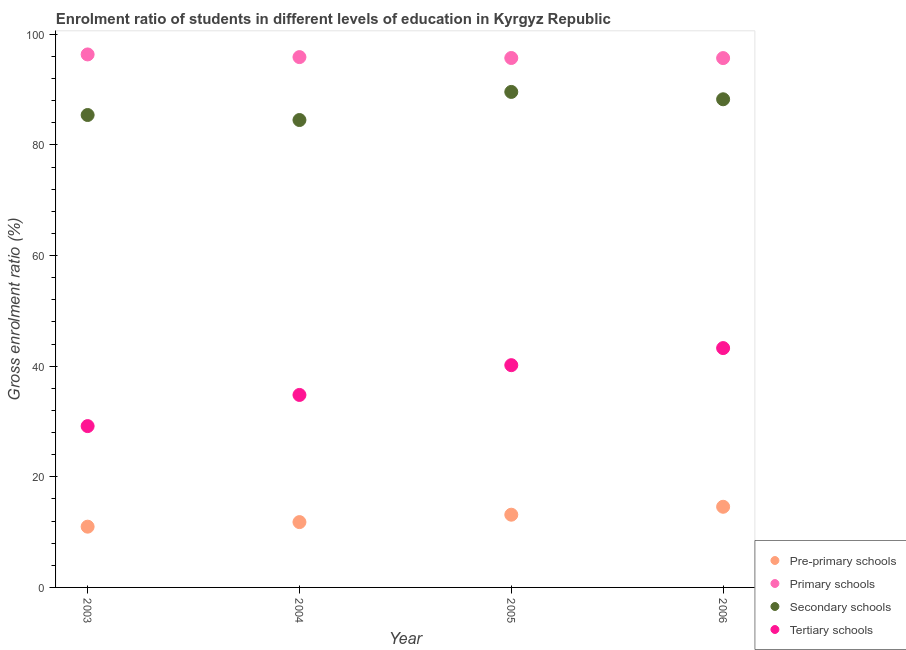How many different coloured dotlines are there?
Ensure brevity in your answer.  4. Is the number of dotlines equal to the number of legend labels?
Offer a very short reply. Yes. What is the gross enrolment ratio in pre-primary schools in 2006?
Make the answer very short. 14.58. Across all years, what is the maximum gross enrolment ratio in tertiary schools?
Offer a terse response. 43.28. Across all years, what is the minimum gross enrolment ratio in pre-primary schools?
Keep it short and to the point. 10.99. In which year was the gross enrolment ratio in pre-primary schools maximum?
Offer a terse response. 2006. What is the total gross enrolment ratio in pre-primary schools in the graph?
Offer a very short reply. 50.53. What is the difference between the gross enrolment ratio in tertiary schools in 2003 and that in 2004?
Your answer should be very brief. -5.63. What is the difference between the gross enrolment ratio in secondary schools in 2003 and the gross enrolment ratio in primary schools in 2006?
Offer a very short reply. -10.29. What is the average gross enrolment ratio in secondary schools per year?
Make the answer very short. 86.95. In the year 2005, what is the difference between the gross enrolment ratio in secondary schools and gross enrolment ratio in tertiary schools?
Give a very brief answer. 49.41. What is the ratio of the gross enrolment ratio in tertiary schools in 2005 to that in 2006?
Your answer should be compact. 0.93. Is the difference between the gross enrolment ratio in tertiary schools in 2003 and 2006 greater than the difference between the gross enrolment ratio in secondary schools in 2003 and 2006?
Provide a succinct answer. No. What is the difference between the highest and the second highest gross enrolment ratio in primary schools?
Make the answer very short. 0.48. What is the difference between the highest and the lowest gross enrolment ratio in tertiary schools?
Your answer should be very brief. 14.11. In how many years, is the gross enrolment ratio in primary schools greater than the average gross enrolment ratio in primary schools taken over all years?
Offer a terse response. 1. Is the sum of the gross enrolment ratio in primary schools in 2004 and 2005 greater than the maximum gross enrolment ratio in secondary schools across all years?
Give a very brief answer. Yes. Is it the case that in every year, the sum of the gross enrolment ratio in tertiary schools and gross enrolment ratio in pre-primary schools is greater than the sum of gross enrolment ratio in primary schools and gross enrolment ratio in secondary schools?
Keep it short and to the point. No. Is it the case that in every year, the sum of the gross enrolment ratio in pre-primary schools and gross enrolment ratio in primary schools is greater than the gross enrolment ratio in secondary schools?
Keep it short and to the point. Yes. Does the gross enrolment ratio in tertiary schools monotonically increase over the years?
Offer a terse response. Yes. Is the gross enrolment ratio in tertiary schools strictly less than the gross enrolment ratio in pre-primary schools over the years?
Provide a short and direct response. No. How many dotlines are there?
Keep it short and to the point. 4. Where does the legend appear in the graph?
Your answer should be compact. Bottom right. What is the title of the graph?
Your answer should be very brief. Enrolment ratio of students in different levels of education in Kyrgyz Republic. What is the label or title of the X-axis?
Your answer should be very brief. Year. What is the Gross enrolment ratio (%) of Pre-primary schools in 2003?
Provide a succinct answer. 10.99. What is the Gross enrolment ratio (%) of Primary schools in 2003?
Provide a succinct answer. 96.37. What is the Gross enrolment ratio (%) of Secondary schools in 2003?
Ensure brevity in your answer.  85.42. What is the Gross enrolment ratio (%) in Tertiary schools in 2003?
Your answer should be very brief. 29.17. What is the Gross enrolment ratio (%) of Pre-primary schools in 2004?
Make the answer very short. 11.81. What is the Gross enrolment ratio (%) of Primary schools in 2004?
Offer a very short reply. 95.89. What is the Gross enrolment ratio (%) of Secondary schools in 2004?
Give a very brief answer. 84.51. What is the Gross enrolment ratio (%) in Tertiary schools in 2004?
Provide a succinct answer. 34.8. What is the Gross enrolment ratio (%) in Pre-primary schools in 2005?
Your answer should be very brief. 13.15. What is the Gross enrolment ratio (%) in Primary schools in 2005?
Give a very brief answer. 95.73. What is the Gross enrolment ratio (%) in Secondary schools in 2005?
Make the answer very short. 89.59. What is the Gross enrolment ratio (%) in Tertiary schools in 2005?
Your answer should be compact. 40.19. What is the Gross enrolment ratio (%) of Pre-primary schools in 2006?
Provide a short and direct response. 14.58. What is the Gross enrolment ratio (%) in Primary schools in 2006?
Your answer should be compact. 95.71. What is the Gross enrolment ratio (%) of Secondary schools in 2006?
Your answer should be very brief. 88.26. What is the Gross enrolment ratio (%) of Tertiary schools in 2006?
Your answer should be compact. 43.28. Across all years, what is the maximum Gross enrolment ratio (%) of Pre-primary schools?
Your answer should be very brief. 14.58. Across all years, what is the maximum Gross enrolment ratio (%) in Primary schools?
Your answer should be very brief. 96.37. Across all years, what is the maximum Gross enrolment ratio (%) of Secondary schools?
Your response must be concise. 89.59. Across all years, what is the maximum Gross enrolment ratio (%) in Tertiary schools?
Keep it short and to the point. 43.28. Across all years, what is the minimum Gross enrolment ratio (%) in Pre-primary schools?
Keep it short and to the point. 10.99. Across all years, what is the minimum Gross enrolment ratio (%) of Primary schools?
Ensure brevity in your answer.  95.71. Across all years, what is the minimum Gross enrolment ratio (%) in Secondary schools?
Give a very brief answer. 84.51. Across all years, what is the minimum Gross enrolment ratio (%) of Tertiary schools?
Your response must be concise. 29.17. What is the total Gross enrolment ratio (%) in Pre-primary schools in the graph?
Ensure brevity in your answer.  50.53. What is the total Gross enrolment ratio (%) of Primary schools in the graph?
Your answer should be very brief. 383.69. What is the total Gross enrolment ratio (%) of Secondary schools in the graph?
Ensure brevity in your answer.  347.78. What is the total Gross enrolment ratio (%) of Tertiary schools in the graph?
Provide a succinct answer. 147.43. What is the difference between the Gross enrolment ratio (%) in Pre-primary schools in 2003 and that in 2004?
Your response must be concise. -0.83. What is the difference between the Gross enrolment ratio (%) of Primary schools in 2003 and that in 2004?
Keep it short and to the point. 0.48. What is the difference between the Gross enrolment ratio (%) in Secondary schools in 2003 and that in 2004?
Provide a short and direct response. 0.91. What is the difference between the Gross enrolment ratio (%) of Tertiary schools in 2003 and that in 2004?
Your answer should be compact. -5.63. What is the difference between the Gross enrolment ratio (%) in Pre-primary schools in 2003 and that in 2005?
Your answer should be compact. -2.17. What is the difference between the Gross enrolment ratio (%) of Primary schools in 2003 and that in 2005?
Your answer should be compact. 0.64. What is the difference between the Gross enrolment ratio (%) of Secondary schools in 2003 and that in 2005?
Your response must be concise. -4.17. What is the difference between the Gross enrolment ratio (%) in Tertiary schools in 2003 and that in 2005?
Offer a terse response. -11.02. What is the difference between the Gross enrolment ratio (%) in Pre-primary schools in 2003 and that in 2006?
Your answer should be very brief. -3.6. What is the difference between the Gross enrolment ratio (%) of Primary schools in 2003 and that in 2006?
Ensure brevity in your answer.  0.66. What is the difference between the Gross enrolment ratio (%) in Secondary schools in 2003 and that in 2006?
Your answer should be compact. -2.84. What is the difference between the Gross enrolment ratio (%) in Tertiary schools in 2003 and that in 2006?
Your answer should be compact. -14.11. What is the difference between the Gross enrolment ratio (%) in Pre-primary schools in 2004 and that in 2005?
Offer a terse response. -1.34. What is the difference between the Gross enrolment ratio (%) in Primary schools in 2004 and that in 2005?
Offer a very short reply. 0.16. What is the difference between the Gross enrolment ratio (%) of Secondary schools in 2004 and that in 2005?
Give a very brief answer. -5.08. What is the difference between the Gross enrolment ratio (%) in Tertiary schools in 2004 and that in 2005?
Provide a short and direct response. -5.38. What is the difference between the Gross enrolment ratio (%) in Pre-primary schools in 2004 and that in 2006?
Ensure brevity in your answer.  -2.77. What is the difference between the Gross enrolment ratio (%) of Primary schools in 2004 and that in 2006?
Give a very brief answer. 0.18. What is the difference between the Gross enrolment ratio (%) of Secondary schools in 2004 and that in 2006?
Offer a terse response. -3.75. What is the difference between the Gross enrolment ratio (%) of Tertiary schools in 2004 and that in 2006?
Keep it short and to the point. -8.47. What is the difference between the Gross enrolment ratio (%) of Pre-primary schools in 2005 and that in 2006?
Give a very brief answer. -1.43. What is the difference between the Gross enrolment ratio (%) in Primary schools in 2005 and that in 2006?
Ensure brevity in your answer.  0.02. What is the difference between the Gross enrolment ratio (%) of Secondary schools in 2005 and that in 2006?
Ensure brevity in your answer.  1.33. What is the difference between the Gross enrolment ratio (%) in Tertiary schools in 2005 and that in 2006?
Make the answer very short. -3.09. What is the difference between the Gross enrolment ratio (%) in Pre-primary schools in 2003 and the Gross enrolment ratio (%) in Primary schools in 2004?
Give a very brief answer. -84.9. What is the difference between the Gross enrolment ratio (%) of Pre-primary schools in 2003 and the Gross enrolment ratio (%) of Secondary schools in 2004?
Offer a very short reply. -73.53. What is the difference between the Gross enrolment ratio (%) in Pre-primary schools in 2003 and the Gross enrolment ratio (%) in Tertiary schools in 2004?
Your answer should be compact. -23.82. What is the difference between the Gross enrolment ratio (%) in Primary schools in 2003 and the Gross enrolment ratio (%) in Secondary schools in 2004?
Your answer should be very brief. 11.86. What is the difference between the Gross enrolment ratio (%) of Primary schools in 2003 and the Gross enrolment ratio (%) of Tertiary schools in 2004?
Offer a terse response. 61.57. What is the difference between the Gross enrolment ratio (%) in Secondary schools in 2003 and the Gross enrolment ratio (%) in Tertiary schools in 2004?
Ensure brevity in your answer.  50.61. What is the difference between the Gross enrolment ratio (%) in Pre-primary schools in 2003 and the Gross enrolment ratio (%) in Primary schools in 2005?
Keep it short and to the point. -84.74. What is the difference between the Gross enrolment ratio (%) in Pre-primary schools in 2003 and the Gross enrolment ratio (%) in Secondary schools in 2005?
Ensure brevity in your answer.  -78.61. What is the difference between the Gross enrolment ratio (%) in Pre-primary schools in 2003 and the Gross enrolment ratio (%) in Tertiary schools in 2005?
Your response must be concise. -29.2. What is the difference between the Gross enrolment ratio (%) of Primary schools in 2003 and the Gross enrolment ratio (%) of Secondary schools in 2005?
Your answer should be compact. 6.78. What is the difference between the Gross enrolment ratio (%) in Primary schools in 2003 and the Gross enrolment ratio (%) in Tertiary schools in 2005?
Provide a succinct answer. 56.18. What is the difference between the Gross enrolment ratio (%) in Secondary schools in 2003 and the Gross enrolment ratio (%) in Tertiary schools in 2005?
Your answer should be very brief. 45.23. What is the difference between the Gross enrolment ratio (%) of Pre-primary schools in 2003 and the Gross enrolment ratio (%) of Primary schools in 2006?
Keep it short and to the point. -84.72. What is the difference between the Gross enrolment ratio (%) of Pre-primary schools in 2003 and the Gross enrolment ratio (%) of Secondary schools in 2006?
Ensure brevity in your answer.  -77.28. What is the difference between the Gross enrolment ratio (%) in Pre-primary schools in 2003 and the Gross enrolment ratio (%) in Tertiary schools in 2006?
Offer a very short reply. -32.29. What is the difference between the Gross enrolment ratio (%) in Primary schools in 2003 and the Gross enrolment ratio (%) in Secondary schools in 2006?
Offer a very short reply. 8.11. What is the difference between the Gross enrolment ratio (%) of Primary schools in 2003 and the Gross enrolment ratio (%) of Tertiary schools in 2006?
Provide a short and direct response. 53.09. What is the difference between the Gross enrolment ratio (%) of Secondary schools in 2003 and the Gross enrolment ratio (%) of Tertiary schools in 2006?
Your answer should be very brief. 42.14. What is the difference between the Gross enrolment ratio (%) in Pre-primary schools in 2004 and the Gross enrolment ratio (%) in Primary schools in 2005?
Offer a terse response. -83.91. What is the difference between the Gross enrolment ratio (%) of Pre-primary schools in 2004 and the Gross enrolment ratio (%) of Secondary schools in 2005?
Offer a very short reply. -77.78. What is the difference between the Gross enrolment ratio (%) in Pre-primary schools in 2004 and the Gross enrolment ratio (%) in Tertiary schools in 2005?
Give a very brief answer. -28.37. What is the difference between the Gross enrolment ratio (%) of Primary schools in 2004 and the Gross enrolment ratio (%) of Secondary schools in 2005?
Provide a short and direct response. 6.3. What is the difference between the Gross enrolment ratio (%) in Primary schools in 2004 and the Gross enrolment ratio (%) in Tertiary schools in 2005?
Offer a terse response. 55.7. What is the difference between the Gross enrolment ratio (%) in Secondary schools in 2004 and the Gross enrolment ratio (%) in Tertiary schools in 2005?
Keep it short and to the point. 44.33. What is the difference between the Gross enrolment ratio (%) of Pre-primary schools in 2004 and the Gross enrolment ratio (%) of Primary schools in 2006?
Ensure brevity in your answer.  -83.9. What is the difference between the Gross enrolment ratio (%) in Pre-primary schools in 2004 and the Gross enrolment ratio (%) in Secondary schools in 2006?
Provide a short and direct response. -76.45. What is the difference between the Gross enrolment ratio (%) of Pre-primary schools in 2004 and the Gross enrolment ratio (%) of Tertiary schools in 2006?
Keep it short and to the point. -31.46. What is the difference between the Gross enrolment ratio (%) in Primary schools in 2004 and the Gross enrolment ratio (%) in Secondary schools in 2006?
Provide a succinct answer. 7.62. What is the difference between the Gross enrolment ratio (%) of Primary schools in 2004 and the Gross enrolment ratio (%) of Tertiary schools in 2006?
Keep it short and to the point. 52.61. What is the difference between the Gross enrolment ratio (%) of Secondary schools in 2004 and the Gross enrolment ratio (%) of Tertiary schools in 2006?
Give a very brief answer. 41.24. What is the difference between the Gross enrolment ratio (%) in Pre-primary schools in 2005 and the Gross enrolment ratio (%) in Primary schools in 2006?
Your answer should be compact. -82.56. What is the difference between the Gross enrolment ratio (%) of Pre-primary schools in 2005 and the Gross enrolment ratio (%) of Secondary schools in 2006?
Your answer should be very brief. -75.11. What is the difference between the Gross enrolment ratio (%) in Pre-primary schools in 2005 and the Gross enrolment ratio (%) in Tertiary schools in 2006?
Give a very brief answer. -30.12. What is the difference between the Gross enrolment ratio (%) of Primary schools in 2005 and the Gross enrolment ratio (%) of Secondary schools in 2006?
Your response must be concise. 7.46. What is the difference between the Gross enrolment ratio (%) of Primary schools in 2005 and the Gross enrolment ratio (%) of Tertiary schools in 2006?
Ensure brevity in your answer.  52.45. What is the difference between the Gross enrolment ratio (%) in Secondary schools in 2005 and the Gross enrolment ratio (%) in Tertiary schools in 2006?
Your answer should be very brief. 46.32. What is the average Gross enrolment ratio (%) of Pre-primary schools per year?
Make the answer very short. 12.63. What is the average Gross enrolment ratio (%) of Primary schools per year?
Your response must be concise. 95.92. What is the average Gross enrolment ratio (%) of Secondary schools per year?
Ensure brevity in your answer.  86.95. What is the average Gross enrolment ratio (%) of Tertiary schools per year?
Ensure brevity in your answer.  36.86. In the year 2003, what is the difference between the Gross enrolment ratio (%) of Pre-primary schools and Gross enrolment ratio (%) of Primary schools?
Keep it short and to the point. -85.38. In the year 2003, what is the difference between the Gross enrolment ratio (%) of Pre-primary schools and Gross enrolment ratio (%) of Secondary schools?
Your answer should be compact. -74.43. In the year 2003, what is the difference between the Gross enrolment ratio (%) in Pre-primary schools and Gross enrolment ratio (%) in Tertiary schools?
Give a very brief answer. -18.18. In the year 2003, what is the difference between the Gross enrolment ratio (%) in Primary schools and Gross enrolment ratio (%) in Secondary schools?
Offer a terse response. 10.95. In the year 2003, what is the difference between the Gross enrolment ratio (%) of Primary schools and Gross enrolment ratio (%) of Tertiary schools?
Provide a succinct answer. 67.2. In the year 2003, what is the difference between the Gross enrolment ratio (%) of Secondary schools and Gross enrolment ratio (%) of Tertiary schools?
Provide a succinct answer. 56.25. In the year 2004, what is the difference between the Gross enrolment ratio (%) of Pre-primary schools and Gross enrolment ratio (%) of Primary schools?
Provide a succinct answer. -84.08. In the year 2004, what is the difference between the Gross enrolment ratio (%) of Pre-primary schools and Gross enrolment ratio (%) of Secondary schools?
Offer a terse response. -72.7. In the year 2004, what is the difference between the Gross enrolment ratio (%) of Pre-primary schools and Gross enrolment ratio (%) of Tertiary schools?
Your answer should be compact. -22.99. In the year 2004, what is the difference between the Gross enrolment ratio (%) in Primary schools and Gross enrolment ratio (%) in Secondary schools?
Your answer should be compact. 11.38. In the year 2004, what is the difference between the Gross enrolment ratio (%) of Primary schools and Gross enrolment ratio (%) of Tertiary schools?
Make the answer very short. 61.08. In the year 2004, what is the difference between the Gross enrolment ratio (%) of Secondary schools and Gross enrolment ratio (%) of Tertiary schools?
Give a very brief answer. 49.71. In the year 2005, what is the difference between the Gross enrolment ratio (%) in Pre-primary schools and Gross enrolment ratio (%) in Primary schools?
Provide a short and direct response. -82.58. In the year 2005, what is the difference between the Gross enrolment ratio (%) of Pre-primary schools and Gross enrolment ratio (%) of Secondary schools?
Provide a short and direct response. -76.44. In the year 2005, what is the difference between the Gross enrolment ratio (%) of Pre-primary schools and Gross enrolment ratio (%) of Tertiary schools?
Ensure brevity in your answer.  -27.04. In the year 2005, what is the difference between the Gross enrolment ratio (%) in Primary schools and Gross enrolment ratio (%) in Secondary schools?
Keep it short and to the point. 6.13. In the year 2005, what is the difference between the Gross enrolment ratio (%) of Primary schools and Gross enrolment ratio (%) of Tertiary schools?
Provide a short and direct response. 55.54. In the year 2005, what is the difference between the Gross enrolment ratio (%) in Secondary schools and Gross enrolment ratio (%) in Tertiary schools?
Ensure brevity in your answer.  49.41. In the year 2006, what is the difference between the Gross enrolment ratio (%) in Pre-primary schools and Gross enrolment ratio (%) in Primary schools?
Your answer should be compact. -81.13. In the year 2006, what is the difference between the Gross enrolment ratio (%) of Pre-primary schools and Gross enrolment ratio (%) of Secondary schools?
Give a very brief answer. -73.68. In the year 2006, what is the difference between the Gross enrolment ratio (%) of Pre-primary schools and Gross enrolment ratio (%) of Tertiary schools?
Keep it short and to the point. -28.69. In the year 2006, what is the difference between the Gross enrolment ratio (%) of Primary schools and Gross enrolment ratio (%) of Secondary schools?
Your answer should be compact. 7.45. In the year 2006, what is the difference between the Gross enrolment ratio (%) in Primary schools and Gross enrolment ratio (%) in Tertiary schools?
Ensure brevity in your answer.  52.43. In the year 2006, what is the difference between the Gross enrolment ratio (%) in Secondary schools and Gross enrolment ratio (%) in Tertiary schools?
Offer a very short reply. 44.99. What is the ratio of the Gross enrolment ratio (%) in Pre-primary schools in 2003 to that in 2004?
Your answer should be very brief. 0.93. What is the ratio of the Gross enrolment ratio (%) of Primary schools in 2003 to that in 2004?
Your answer should be very brief. 1. What is the ratio of the Gross enrolment ratio (%) in Secondary schools in 2003 to that in 2004?
Offer a very short reply. 1.01. What is the ratio of the Gross enrolment ratio (%) in Tertiary schools in 2003 to that in 2004?
Your answer should be very brief. 0.84. What is the ratio of the Gross enrolment ratio (%) in Pre-primary schools in 2003 to that in 2005?
Make the answer very short. 0.84. What is the ratio of the Gross enrolment ratio (%) in Secondary schools in 2003 to that in 2005?
Your answer should be very brief. 0.95. What is the ratio of the Gross enrolment ratio (%) in Tertiary schools in 2003 to that in 2005?
Ensure brevity in your answer.  0.73. What is the ratio of the Gross enrolment ratio (%) of Pre-primary schools in 2003 to that in 2006?
Your answer should be very brief. 0.75. What is the ratio of the Gross enrolment ratio (%) in Secondary schools in 2003 to that in 2006?
Make the answer very short. 0.97. What is the ratio of the Gross enrolment ratio (%) of Tertiary schools in 2003 to that in 2006?
Give a very brief answer. 0.67. What is the ratio of the Gross enrolment ratio (%) of Pre-primary schools in 2004 to that in 2005?
Give a very brief answer. 0.9. What is the ratio of the Gross enrolment ratio (%) in Primary schools in 2004 to that in 2005?
Your answer should be compact. 1. What is the ratio of the Gross enrolment ratio (%) of Secondary schools in 2004 to that in 2005?
Offer a very short reply. 0.94. What is the ratio of the Gross enrolment ratio (%) in Tertiary schools in 2004 to that in 2005?
Provide a succinct answer. 0.87. What is the ratio of the Gross enrolment ratio (%) in Pre-primary schools in 2004 to that in 2006?
Ensure brevity in your answer.  0.81. What is the ratio of the Gross enrolment ratio (%) of Secondary schools in 2004 to that in 2006?
Offer a terse response. 0.96. What is the ratio of the Gross enrolment ratio (%) in Tertiary schools in 2004 to that in 2006?
Keep it short and to the point. 0.8. What is the ratio of the Gross enrolment ratio (%) of Pre-primary schools in 2005 to that in 2006?
Make the answer very short. 0.9. What is the ratio of the Gross enrolment ratio (%) in Secondary schools in 2005 to that in 2006?
Give a very brief answer. 1.02. What is the ratio of the Gross enrolment ratio (%) in Tertiary schools in 2005 to that in 2006?
Offer a terse response. 0.93. What is the difference between the highest and the second highest Gross enrolment ratio (%) of Pre-primary schools?
Make the answer very short. 1.43. What is the difference between the highest and the second highest Gross enrolment ratio (%) in Primary schools?
Your answer should be compact. 0.48. What is the difference between the highest and the second highest Gross enrolment ratio (%) in Secondary schools?
Ensure brevity in your answer.  1.33. What is the difference between the highest and the second highest Gross enrolment ratio (%) in Tertiary schools?
Your response must be concise. 3.09. What is the difference between the highest and the lowest Gross enrolment ratio (%) of Pre-primary schools?
Keep it short and to the point. 3.6. What is the difference between the highest and the lowest Gross enrolment ratio (%) in Primary schools?
Your answer should be very brief. 0.66. What is the difference between the highest and the lowest Gross enrolment ratio (%) in Secondary schools?
Offer a very short reply. 5.08. What is the difference between the highest and the lowest Gross enrolment ratio (%) of Tertiary schools?
Offer a very short reply. 14.11. 